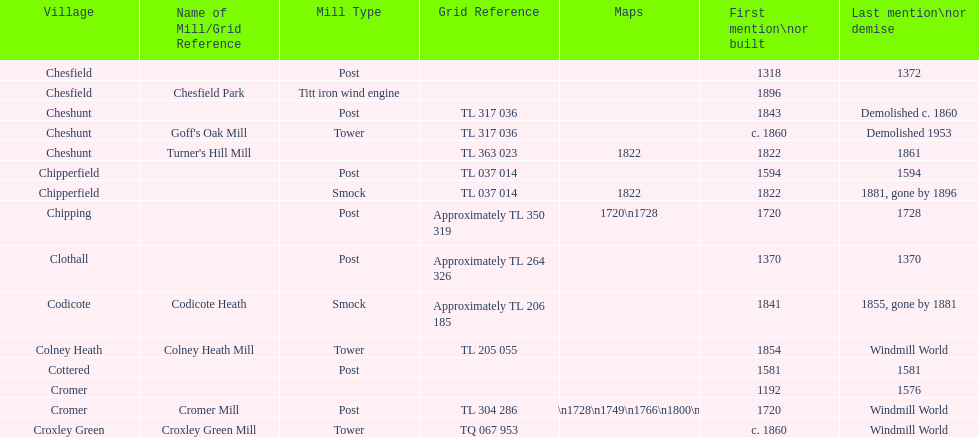What is the total number of mills named cheshunt? 3. 